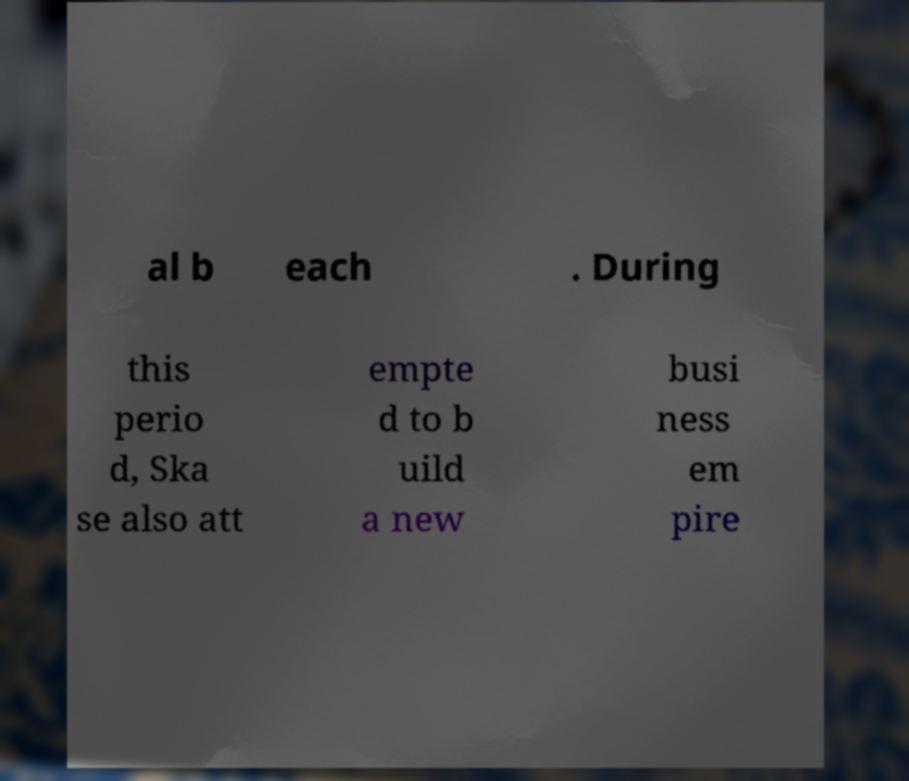What messages or text are displayed in this image? I need them in a readable, typed format. al b each . During this perio d, Ska se also att empte d to b uild a new busi ness em pire 